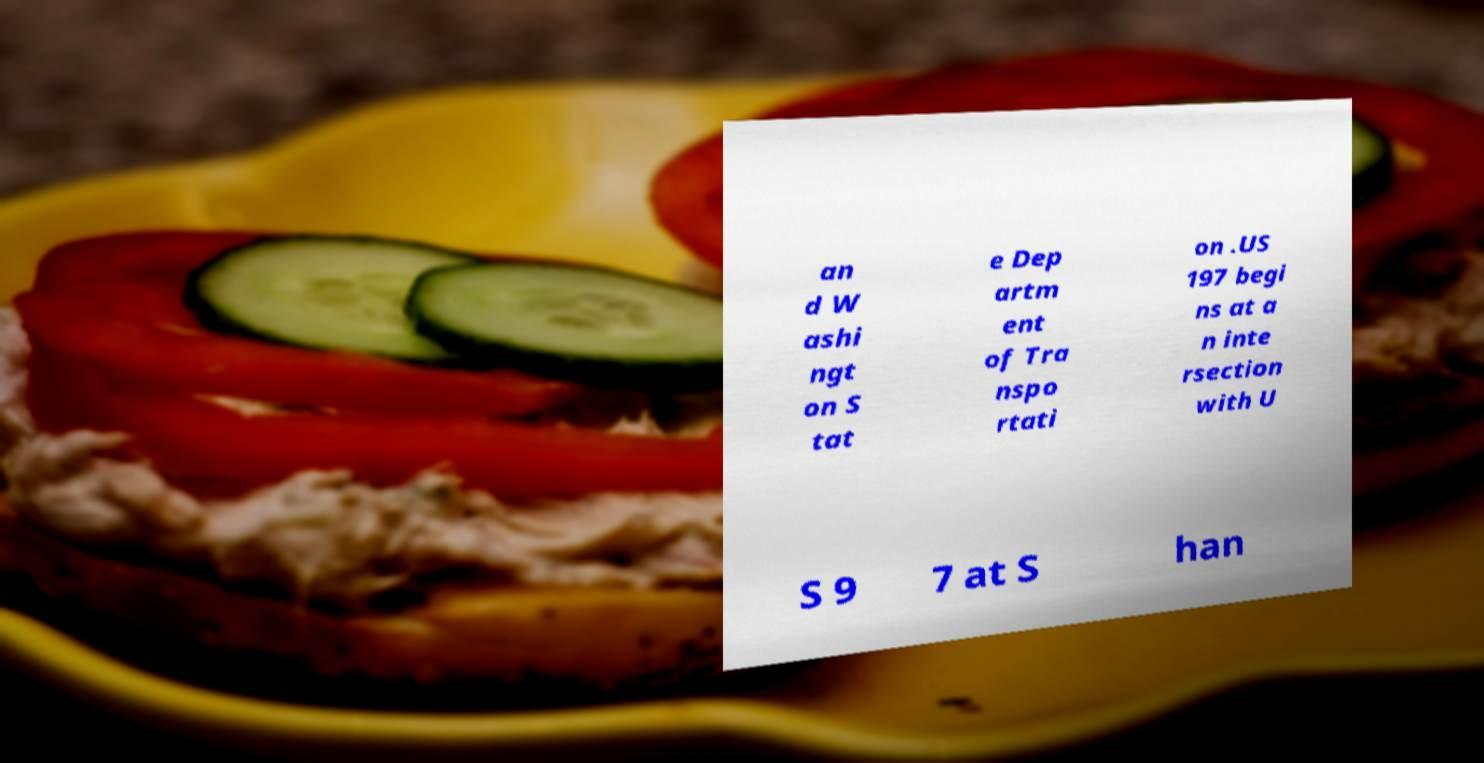What messages or text are displayed in this image? I need them in a readable, typed format. an d W ashi ngt on S tat e Dep artm ent of Tra nspo rtati on .US 197 begi ns at a n inte rsection with U S 9 7 at S han 